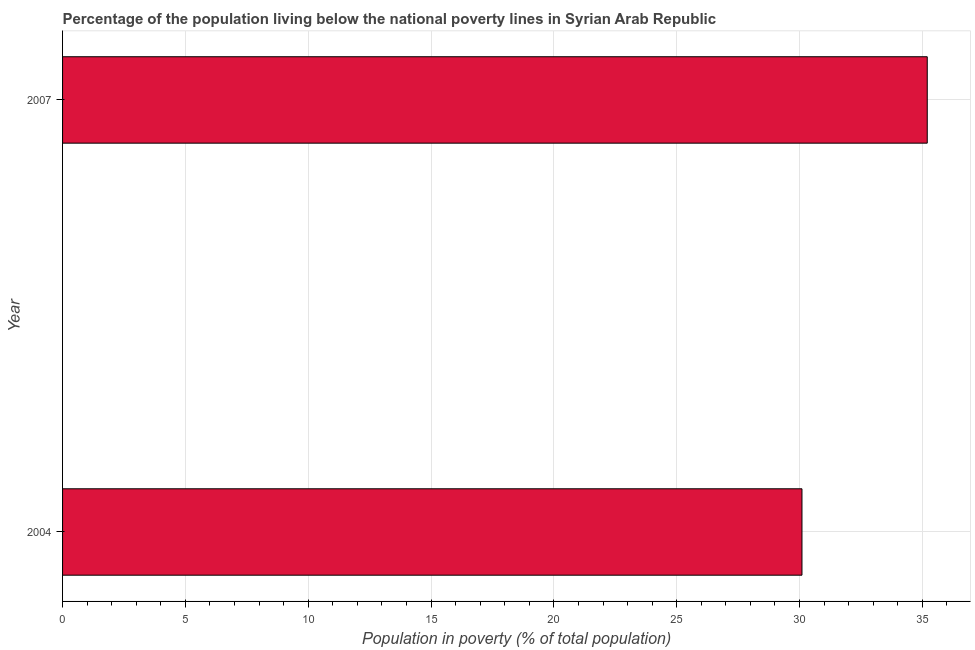Does the graph contain any zero values?
Your answer should be compact. No. What is the title of the graph?
Offer a very short reply. Percentage of the population living below the national poverty lines in Syrian Arab Republic. What is the label or title of the X-axis?
Keep it short and to the point. Population in poverty (% of total population). What is the label or title of the Y-axis?
Keep it short and to the point. Year. What is the percentage of population living below poverty line in 2004?
Offer a very short reply. 30.1. Across all years, what is the maximum percentage of population living below poverty line?
Keep it short and to the point. 35.2. Across all years, what is the minimum percentage of population living below poverty line?
Provide a short and direct response. 30.1. In which year was the percentage of population living below poverty line maximum?
Your answer should be compact. 2007. In which year was the percentage of population living below poverty line minimum?
Ensure brevity in your answer.  2004. What is the sum of the percentage of population living below poverty line?
Your answer should be very brief. 65.3. What is the difference between the percentage of population living below poverty line in 2004 and 2007?
Ensure brevity in your answer.  -5.1. What is the average percentage of population living below poverty line per year?
Provide a short and direct response. 32.65. What is the median percentage of population living below poverty line?
Offer a terse response. 32.65. In how many years, is the percentage of population living below poverty line greater than 15 %?
Your response must be concise. 2. Do a majority of the years between 2007 and 2004 (inclusive) have percentage of population living below poverty line greater than 20 %?
Provide a short and direct response. No. What is the ratio of the percentage of population living below poverty line in 2004 to that in 2007?
Provide a succinct answer. 0.85. In how many years, is the percentage of population living below poverty line greater than the average percentage of population living below poverty line taken over all years?
Make the answer very short. 1. How many bars are there?
Your answer should be very brief. 2. How many years are there in the graph?
Provide a succinct answer. 2. What is the difference between two consecutive major ticks on the X-axis?
Offer a very short reply. 5. Are the values on the major ticks of X-axis written in scientific E-notation?
Offer a very short reply. No. What is the Population in poverty (% of total population) in 2004?
Offer a terse response. 30.1. What is the Population in poverty (% of total population) of 2007?
Give a very brief answer. 35.2. What is the ratio of the Population in poverty (% of total population) in 2004 to that in 2007?
Offer a very short reply. 0.85. 